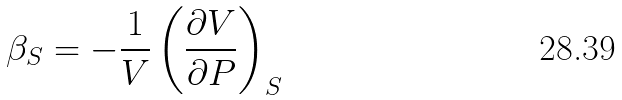Convert formula to latex. <formula><loc_0><loc_0><loc_500><loc_500>\beta _ { S } = - { \frac { 1 } { V } } \left ( { \frac { \partial V } { \partial P } } \right ) _ { S }</formula> 